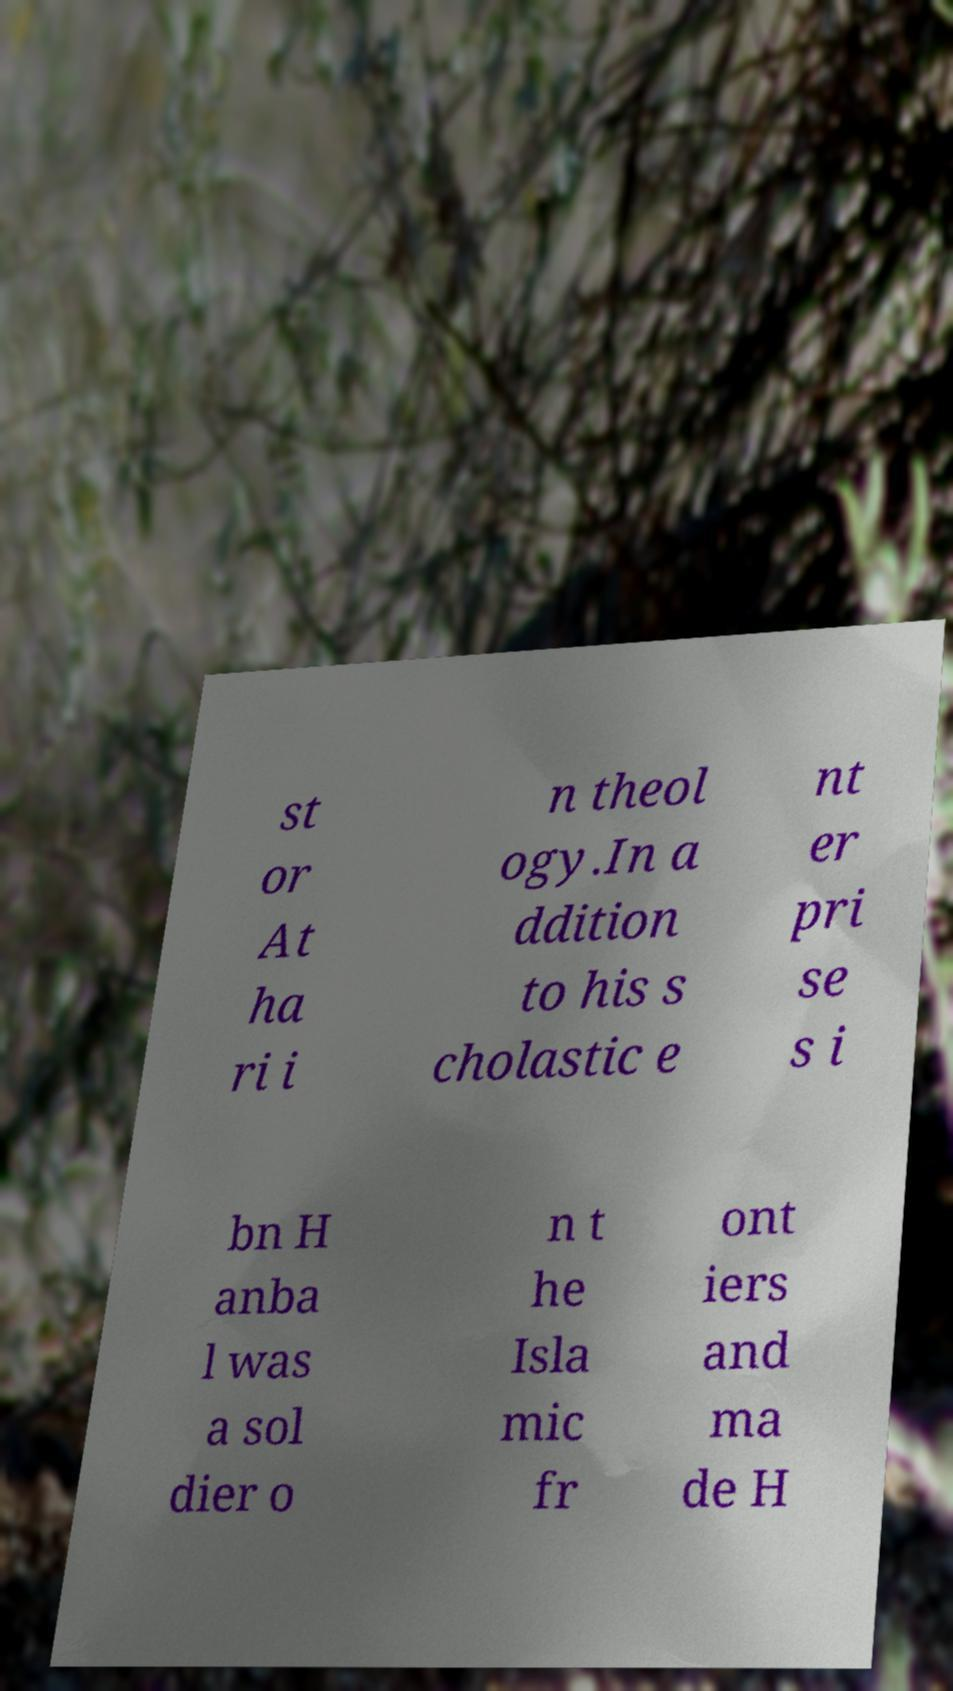Can you read and provide the text displayed in the image?This photo seems to have some interesting text. Can you extract and type it out for me? st or At ha ri i n theol ogy.In a ddition to his s cholastic e nt er pri se s i bn H anba l was a sol dier o n t he Isla mic fr ont iers and ma de H 